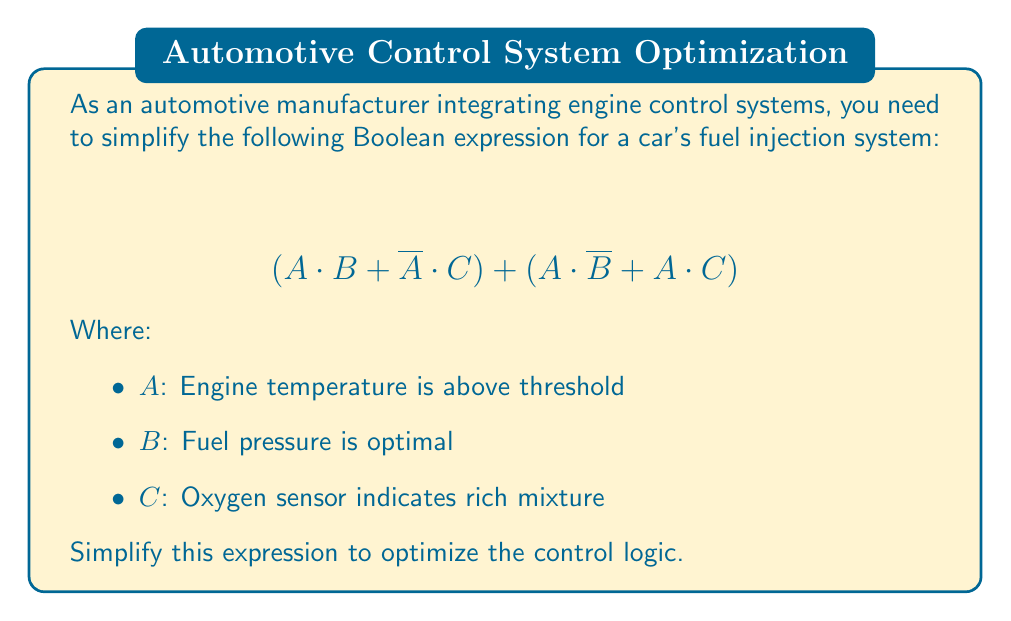Solve this math problem. Let's simplify this Boolean expression step by step:

1) First, let's distribute A in the second term:
   $$(A \cdot B + \overline{A} \cdot C) + (A \cdot \overline{B} + A \cdot C)$$
   $$= (A \cdot B + \overline{A} \cdot C) + A \cdot (\overline{B} + C)$$

2) Now, we can apply the distributive law to the whole expression:
   $$= A \cdot B + \overline{A} \cdot C + A \cdot \overline{B} + A \cdot C$$

3) Group terms with A and terms with C:
   $$= (A \cdot B + A \cdot \overline{B}) + (A \cdot C + \overline{A} \cdot C)$$

4) In the first parenthesis, we can factor out A:
   $$= A \cdot (B + \overline{B}) + (A \cdot C + \overline{A} \cdot C)$$

5) $(B + \overline{B})$ always evaluates to 1, so:
   $$= A + (A \cdot C + \overline{A} \cdot C)$$

6) In the second parenthesis, we can factor out C:
   $$= A + C \cdot (A + \overline{A})$$

7) $(A + \overline{A})$ always evaluates to 1, so:
   $$= A + C$$

This is the simplest form of the original expression.
Answer: $$A + C$$ 